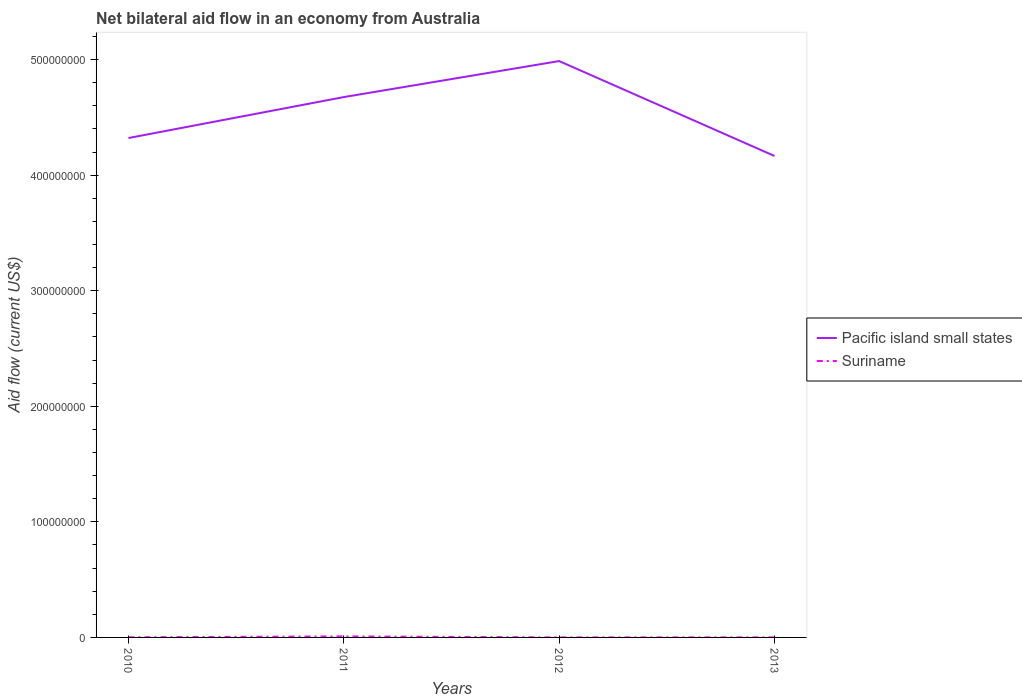How many different coloured lines are there?
Make the answer very short. 2. Is the number of lines equal to the number of legend labels?
Make the answer very short. Yes. Across all years, what is the maximum net bilateral aid flow in Suriname?
Ensure brevity in your answer.  2.00e+04. In which year was the net bilateral aid flow in Pacific island small states maximum?
Offer a terse response. 2013. What is the total net bilateral aid flow in Suriname in the graph?
Offer a very short reply. 8.70e+05. What is the difference between the highest and the second highest net bilateral aid flow in Pacific island small states?
Your response must be concise. 8.21e+07. What is the difference between the highest and the lowest net bilateral aid flow in Pacific island small states?
Offer a terse response. 2. How many lines are there?
Provide a short and direct response. 2. How many years are there in the graph?
Offer a terse response. 4. Does the graph contain grids?
Provide a succinct answer. No. Where does the legend appear in the graph?
Your answer should be very brief. Center right. How are the legend labels stacked?
Provide a succinct answer. Vertical. What is the title of the graph?
Your response must be concise. Net bilateral aid flow in an economy from Australia. What is the label or title of the X-axis?
Offer a very short reply. Years. What is the label or title of the Y-axis?
Keep it short and to the point. Aid flow (current US$). What is the Aid flow (current US$) of Pacific island small states in 2010?
Give a very brief answer. 4.32e+08. What is the Aid flow (current US$) of Suriname in 2010?
Your answer should be very brief. 1.10e+05. What is the Aid flow (current US$) in Pacific island small states in 2011?
Your answer should be compact. 4.68e+08. What is the Aid flow (current US$) of Suriname in 2011?
Offer a very short reply. 8.90e+05. What is the Aid flow (current US$) of Pacific island small states in 2012?
Keep it short and to the point. 4.99e+08. What is the Aid flow (current US$) of Suriname in 2012?
Ensure brevity in your answer.  2.00e+04. What is the Aid flow (current US$) of Pacific island small states in 2013?
Provide a short and direct response. 4.17e+08. Across all years, what is the maximum Aid flow (current US$) in Pacific island small states?
Give a very brief answer. 4.99e+08. Across all years, what is the maximum Aid flow (current US$) in Suriname?
Your answer should be very brief. 8.90e+05. Across all years, what is the minimum Aid flow (current US$) of Pacific island small states?
Ensure brevity in your answer.  4.17e+08. What is the total Aid flow (current US$) of Pacific island small states in the graph?
Keep it short and to the point. 1.81e+09. What is the total Aid flow (current US$) of Suriname in the graph?
Your response must be concise. 1.07e+06. What is the difference between the Aid flow (current US$) of Pacific island small states in 2010 and that in 2011?
Give a very brief answer. -3.54e+07. What is the difference between the Aid flow (current US$) of Suriname in 2010 and that in 2011?
Ensure brevity in your answer.  -7.80e+05. What is the difference between the Aid flow (current US$) in Pacific island small states in 2010 and that in 2012?
Give a very brief answer. -6.66e+07. What is the difference between the Aid flow (current US$) in Pacific island small states in 2010 and that in 2013?
Your answer should be very brief. 1.55e+07. What is the difference between the Aid flow (current US$) in Pacific island small states in 2011 and that in 2012?
Give a very brief answer. -3.12e+07. What is the difference between the Aid flow (current US$) in Suriname in 2011 and that in 2012?
Give a very brief answer. 8.70e+05. What is the difference between the Aid flow (current US$) of Pacific island small states in 2011 and that in 2013?
Your answer should be compact. 5.10e+07. What is the difference between the Aid flow (current US$) of Suriname in 2011 and that in 2013?
Make the answer very short. 8.40e+05. What is the difference between the Aid flow (current US$) in Pacific island small states in 2012 and that in 2013?
Give a very brief answer. 8.21e+07. What is the difference between the Aid flow (current US$) in Suriname in 2012 and that in 2013?
Offer a terse response. -3.00e+04. What is the difference between the Aid flow (current US$) of Pacific island small states in 2010 and the Aid flow (current US$) of Suriname in 2011?
Make the answer very short. 4.31e+08. What is the difference between the Aid flow (current US$) in Pacific island small states in 2010 and the Aid flow (current US$) in Suriname in 2012?
Ensure brevity in your answer.  4.32e+08. What is the difference between the Aid flow (current US$) of Pacific island small states in 2010 and the Aid flow (current US$) of Suriname in 2013?
Provide a succinct answer. 4.32e+08. What is the difference between the Aid flow (current US$) of Pacific island small states in 2011 and the Aid flow (current US$) of Suriname in 2012?
Make the answer very short. 4.68e+08. What is the difference between the Aid flow (current US$) of Pacific island small states in 2011 and the Aid flow (current US$) of Suriname in 2013?
Provide a short and direct response. 4.68e+08. What is the difference between the Aid flow (current US$) of Pacific island small states in 2012 and the Aid flow (current US$) of Suriname in 2013?
Your answer should be compact. 4.99e+08. What is the average Aid flow (current US$) in Pacific island small states per year?
Keep it short and to the point. 4.54e+08. What is the average Aid flow (current US$) of Suriname per year?
Your answer should be compact. 2.68e+05. In the year 2010, what is the difference between the Aid flow (current US$) of Pacific island small states and Aid flow (current US$) of Suriname?
Provide a succinct answer. 4.32e+08. In the year 2011, what is the difference between the Aid flow (current US$) in Pacific island small states and Aid flow (current US$) in Suriname?
Give a very brief answer. 4.67e+08. In the year 2012, what is the difference between the Aid flow (current US$) in Pacific island small states and Aid flow (current US$) in Suriname?
Your response must be concise. 4.99e+08. In the year 2013, what is the difference between the Aid flow (current US$) in Pacific island small states and Aid flow (current US$) in Suriname?
Keep it short and to the point. 4.17e+08. What is the ratio of the Aid flow (current US$) in Pacific island small states in 2010 to that in 2011?
Give a very brief answer. 0.92. What is the ratio of the Aid flow (current US$) of Suriname in 2010 to that in 2011?
Ensure brevity in your answer.  0.12. What is the ratio of the Aid flow (current US$) in Pacific island small states in 2010 to that in 2012?
Your answer should be very brief. 0.87. What is the ratio of the Aid flow (current US$) in Pacific island small states in 2010 to that in 2013?
Your answer should be compact. 1.04. What is the ratio of the Aid flow (current US$) of Suriname in 2010 to that in 2013?
Provide a succinct answer. 2.2. What is the ratio of the Aid flow (current US$) in Pacific island small states in 2011 to that in 2012?
Offer a very short reply. 0.94. What is the ratio of the Aid flow (current US$) in Suriname in 2011 to that in 2012?
Your answer should be compact. 44.5. What is the ratio of the Aid flow (current US$) of Pacific island small states in 2011 to that in 2013?
Offer a very short reply. 1.12. What is the ratio of the Aid flow (current US$) of Pacific island small states in 2012 to that in 2013?
Provide a short and direct response. 1.2. What is the ratio of the Aid flow (current US$) in Suriname in 2012 to that in 2013?
Give a very brief answer. 0.4. What is the difference between the highest and the second highest Aid flow (current US$) of Pacific island small states?
Make the answer very short. 3.12e+07. What is the difference between the highest and the second highest Aid flow (current US$) of Suriname?
Provide a succinct answer. 7.80e+05. What is the difference between the highest and the lowest Aid flow (current US$) of Pacific island small states?
Your answer should be very brief. 8.21e+07. What is the difference between the highest and the lowest Aid flow (current US$) in Suriname?
Give a very brief answer. 8.70e+05. 